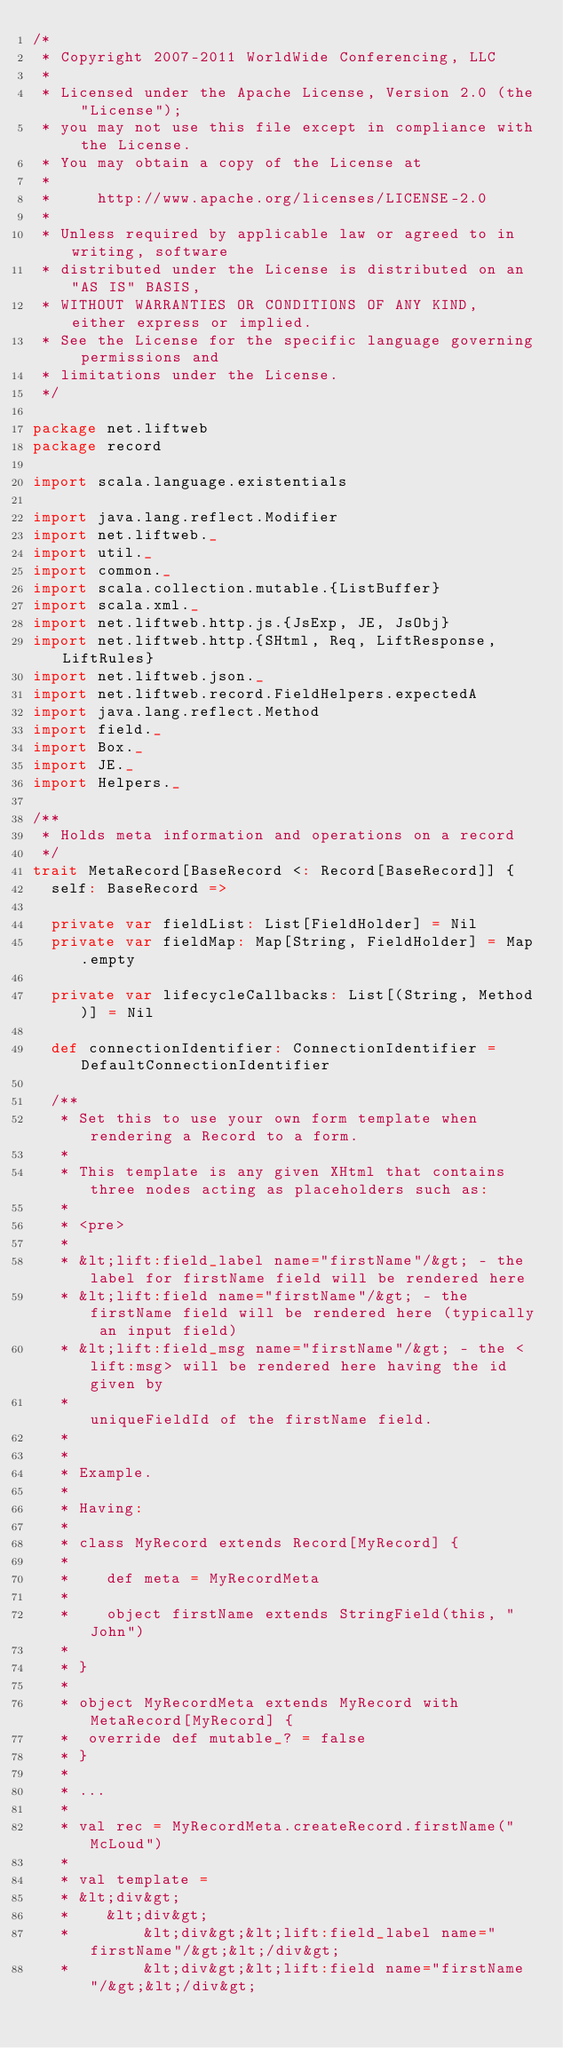<code> <loc_0><loc_0><loc_500><loc_500><_Scala_>/*
 * Copyright 2007-2011 WorldWide Conferencing, LLC
 *
 * Licensed under the Apache License, Version 2.0 (the "License");
 * you may not use this file except in compliance with the License.
 * You may obtain a copy of the License at
 *
 *     http://www.apache.org/licenses/LICENSE-2.0
 *
 * Unless required by applicable law or agreed to in writing, software
 * distributed under the License is distributed on an "AS IS" BASIS,
 * WITHOUT WARRANTIES OR CONDITIONS OF ANY KIND, either express or implied.
 * See the License for the specific language governing permissions and
 * limitations under the License.
 */

package net.liftweb
package record

import scala.language.existentials

import java.lang.reflect.Modifier
import net.liftweb._
import util._
import common._
import scala.collection.mutable.{ListBuffer}
import scala.xml._
import net.liftweb.http.js.{JsExp, JE, JsObj}
import net.liftweb.http.{SHtml, Req, LiftResponse, LiftRules}
import net.liftweb.json._
import net.liftweb.record.FieldHelpers.expectedA
import java.lang.reflect.Method
import field._
import Box._
import JE._
import Helpers._

/**
 * Holds meta information and operations on a record
 */
trait MetaRecord[BaseRecord <: Record[BaseRecord]] {
  self: BaseRecord =>

  private var fieldList: List[FieldHolder] = Nil
  private var fieldMap: Map[String, FieldHolder] = Map.empty

  private var lifecycleCallbacks: List[(String, Method)] = Nil

  def connectionIdentifier: ConnectionIdentifier = DefaultConnectionIdentifier

  /**
   * Set this to use your own form template when rendering a Record to a form.
   *
   * This template is any given XHtml that contains three nodes acting as placeholders such as:
   *
   * <pre>
   *
   * &lt;lift:field_label name="firstName"/&gt; - the label for firstName field will be rendered here
   * &lt;lift:field name="firstName"/&gt; - the firstName field will be rendered here (typically an input field)
   * &lt;lift:field_msg name="firstName"/&gt; - the <lift:msg> will be rendered here having the id given by
   *                                             uniqueFieldId of the firstName field.
   *
   *
   * Example.
   *
   * Having:
   *
   * class MyRecord extends Record[MyRecord] {
   *
   * 	def meta = MyRecordMeta
   *
   * 	object firstName extends StringField(this, "John")
   *
   * }
   *
   * object MyRecordMeta extends MyRecord with MetaRecord[MyRecord] {
   *  override def mutable_? = false
   * }
   *
   * ...
   *
   * val rec = MyRecordMeta.createRecord.firstName("McLoud")
   *
   * val template =
   * &lt;div&gt;
   * 	&lt;div&gt;
   * 		&lt;div&gt;&lt;lift:field_label name="firstName"/&gt;&lt;/div&gt;
   * 		&lt;div&gt;&lt;lift:field name="firstName"/&gt;&lt;/div&gt;</code> 